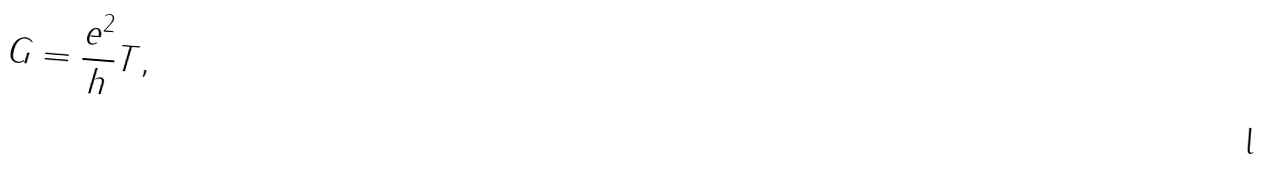<formula> <loc_0><loc_0><loc_500><loc_500>G = \frac { e ^ { 2 } } { h } T ,</formula> 